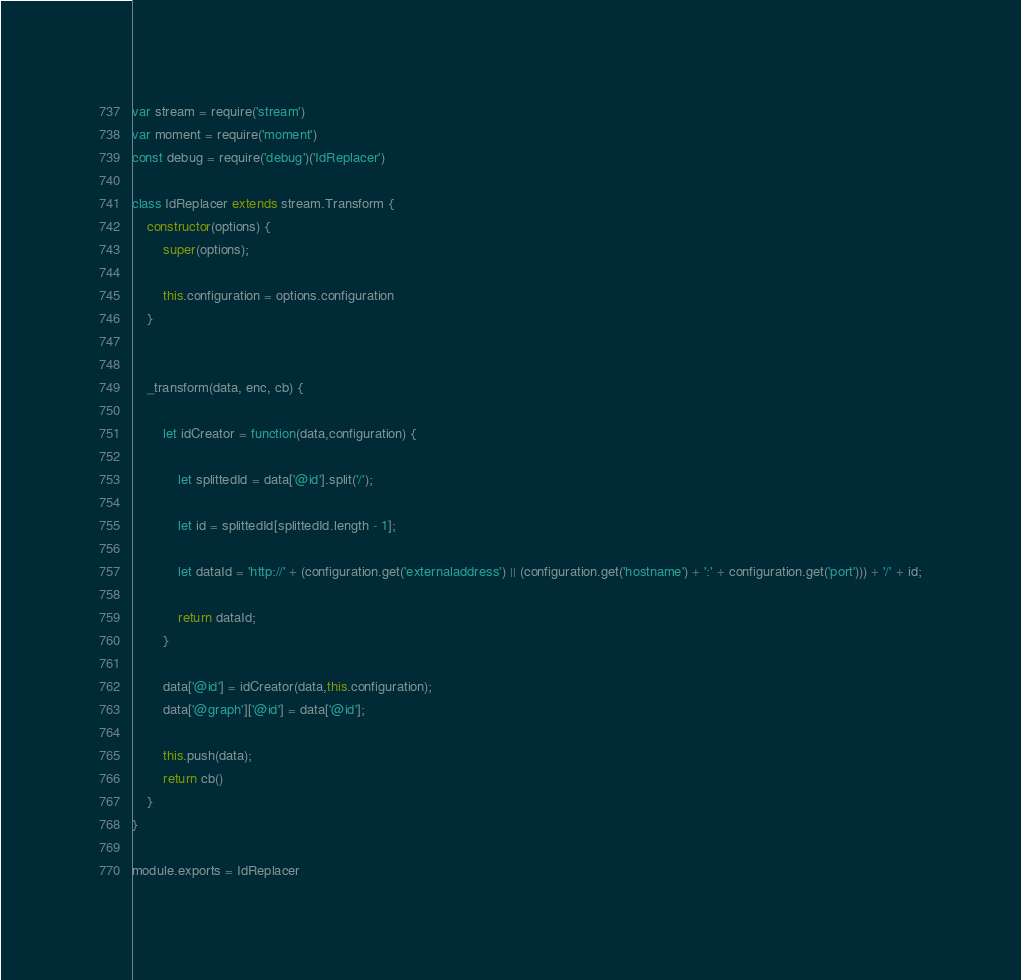Convert code to text. <code><loc_0><loc_0><loc_500><loc_500><_JavaScript_>var stream = require('stream')
var moment = require('moment')
const debug = require('debug')('IdReplacer')

class IdReplacer extends stream.Transform {
    constructor(options) {
        super(options);

        this.configuration = options.configuration
    }


    _transform(data, enc, cb) {

        let idCreator = function(data,configuration) {

            let splittedId = data['@id'].split('/');

            let id = splittedId[splittedId.length - 1];

            let dataId = 'http://' + (configuration.get('externaladdress') || (configuration.get('hostname') + ':' + configuration.get('port'))) + '/' + id;

            return dataId;
        }

        data['@id'] = idCreator(data,this.configuration);
        data['@graph']['@id'] = data['@id'];

        this.push(data);
        return cb()
    }
}

module.exports = IdReplacer
</code> 